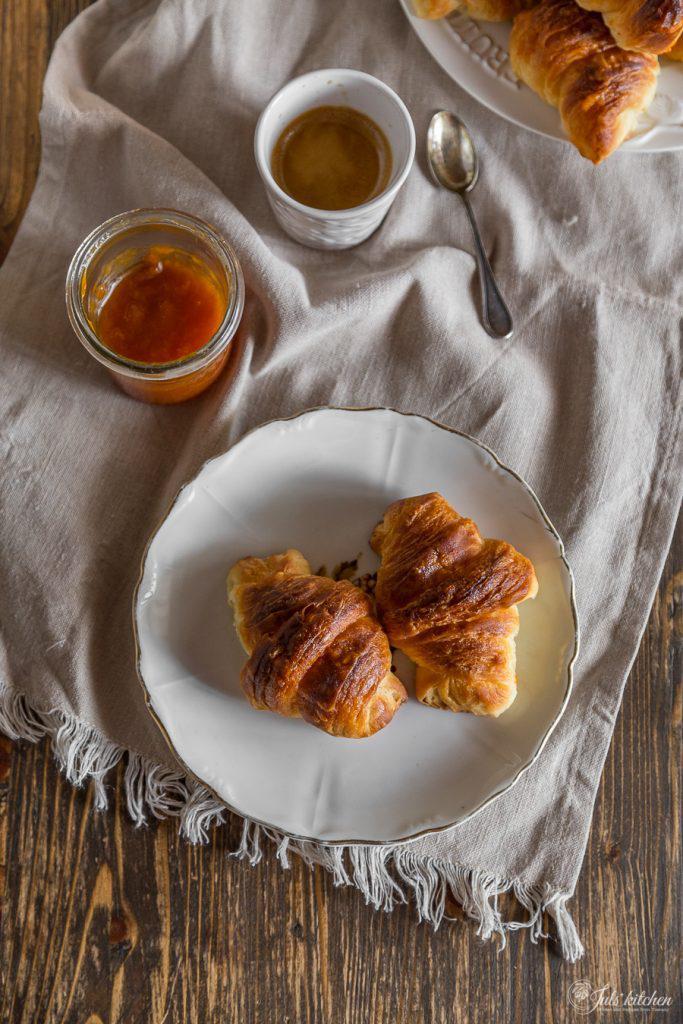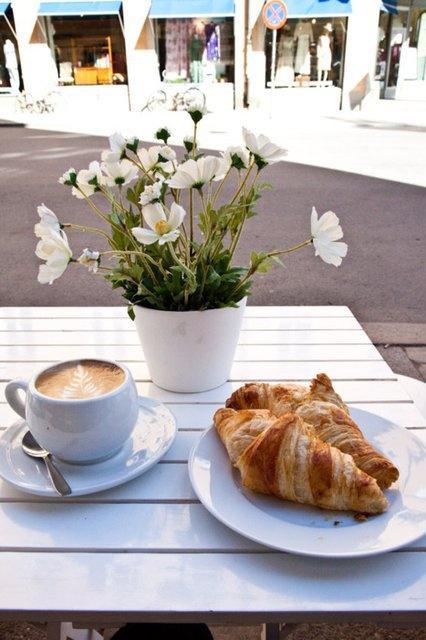The first image is the image on the left, the second image is the image on the right. Evaluate the accuracy of this statement regarding the images: "One of the images has a human being visible.". Is it true? Answer yes or no. No. The first image is the image on the left, the second image is the image on the right. Given the left and right images, does the statement "The left and right image contains the same number of cups with at least two pastries." hold true? Answer yes or no. No. 